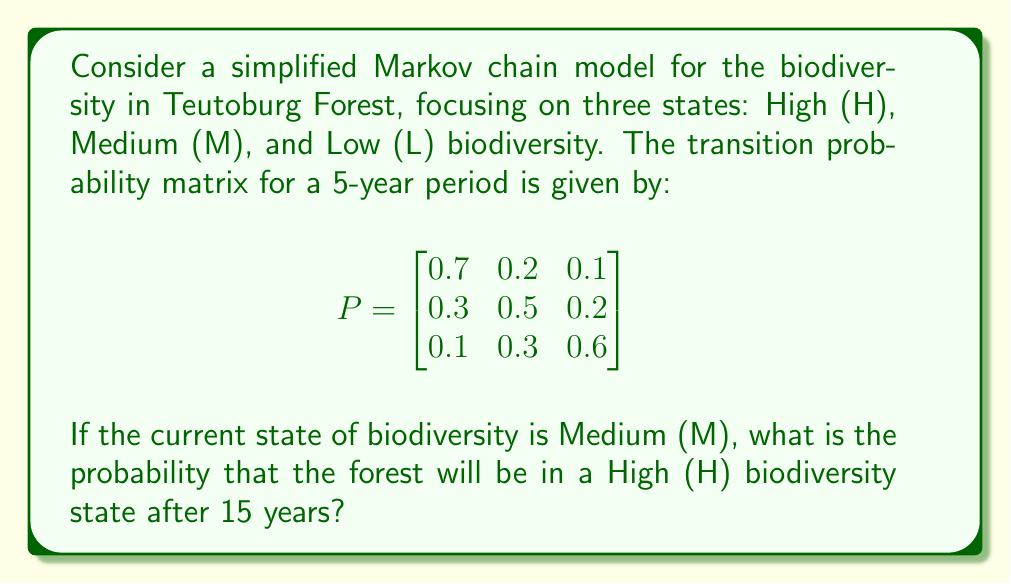Could you help me with this problem? To solve this problem, we need to calculate the 3-step transition probability matrix, as each step represents a 5-year period, and we want to know the state after 15 years (3 * 5 years).

Step 1: Calculate $P^3$
We can use the Chapman-Kolmogorov equations, which state that $P^n = P \cdot P^{n-1}$. So, we need to multiply $P$ by itself three times.

$P^2 = P \cdot P = \begin{bmatrix}
0.58 & 0.26 & 0.16 \\
0.37 & 0.43 & 0.20 \\
0.22 & 0.33 & 0.45
\end{bmatrix}$

$P^3 = P \cdot P^2 = \begin{bmatrix}
0.527 & 0.281 & 0.192 \\
0.401 & 0.356 & 0.243 \\
0.292 & 0.327 & 0.381
\end{bmatrix}$

Step 2: Interpret the result
The entry in the first column and second row of $P^3$ represents the probability of transitioning from Medium (M) to High (H) biodiversity state after 15 years.

Therefore, the probability of transitioning from Medium (M) to High (H) after 15 years is 0.401 or 40.1%.
Answer: 0.401 